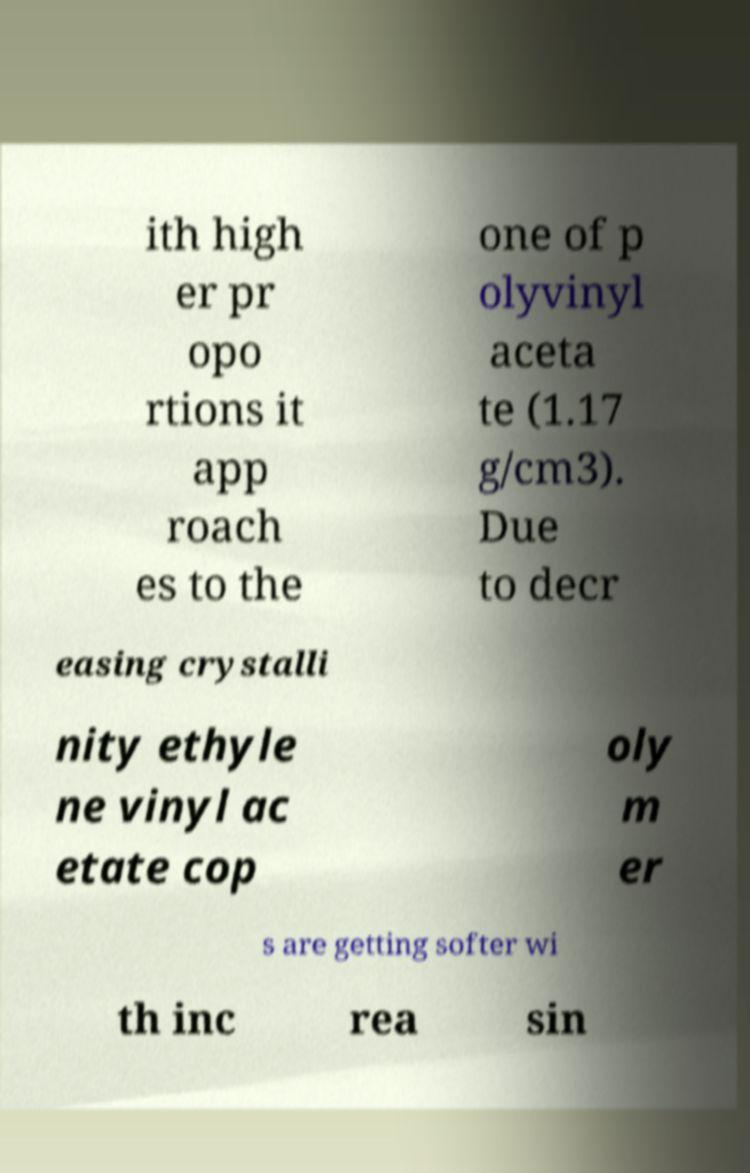Please read and relay the text visible in this image. What does it say? ith high er pr opo rtions it app roach es to the one of p olyvinyl aceta te (1.17 g/cm3). Due to decr easing crystalli nity ethyle ne vinyl ac etate cop oly m er s are getting softer wi th inc rea sin 